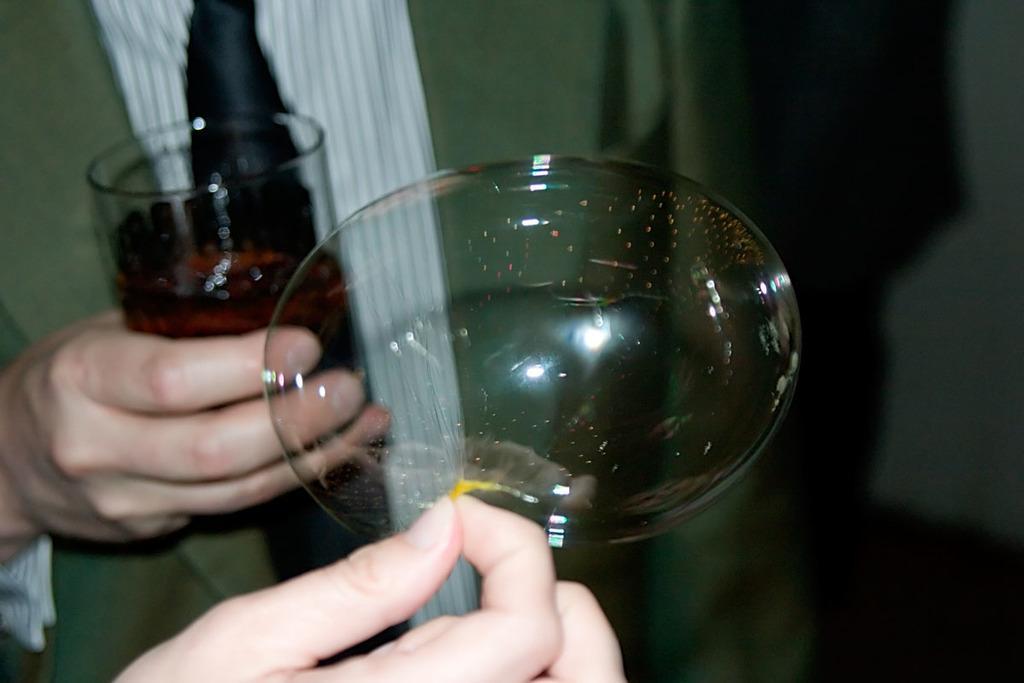Describe this image in one or two sentences. This picture shows a human holding a glass in his hand and we see a air bubble and another human hand. 